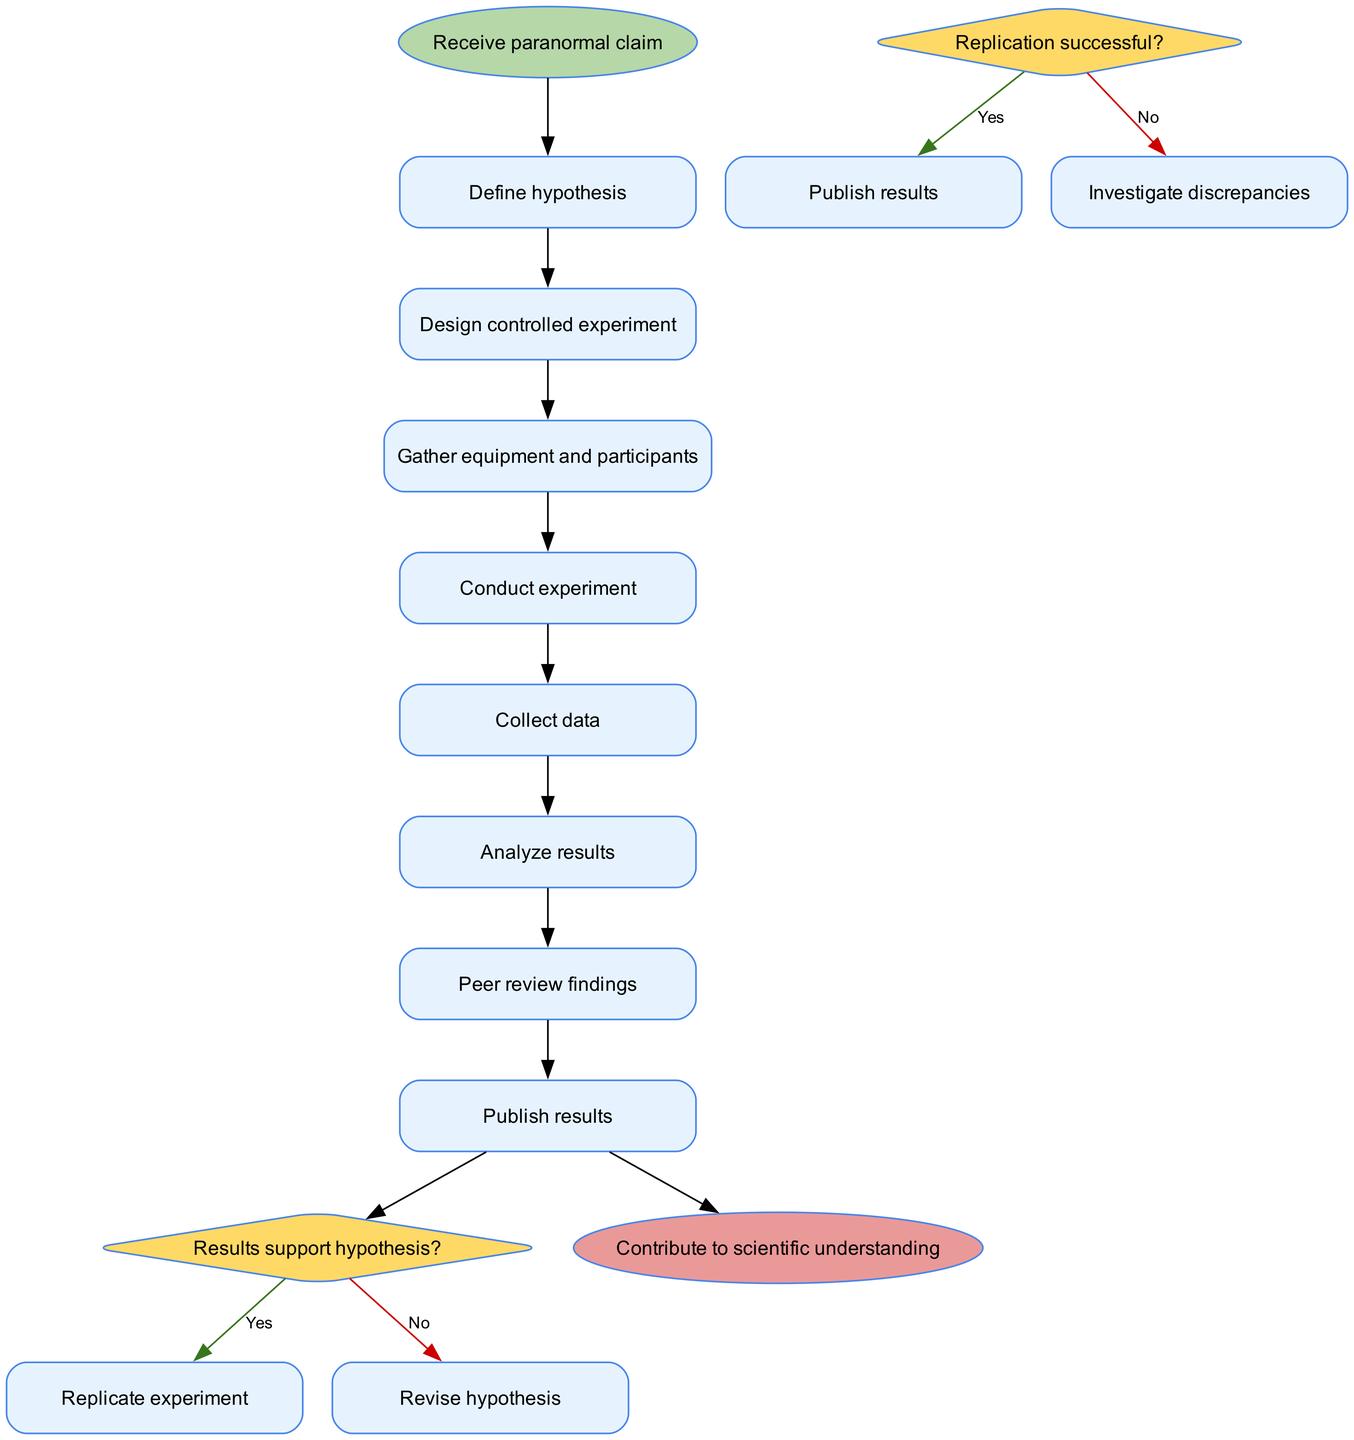What is the first activity in the diagram? The first activity is identified by its position and connection in the diagram, which follows the start node. It is labeled as "Define hypothesis."
Answer: Define hypothesis How many activities are present in the diagram? By counting each listed activity from the diagram data, there are a total of 8 activities mentioned.
Answer: 8 What happens if the results do not support the hypothesis? This can be deduced by tracing the decision flow from the "Results support hypothesis?" decision node; if the answer is "No," the next step is to "Revise hypothesis."
Answer: Revise hypothesis Which node leads to collecting data? The node that leads to "Collect data" is "Conduct experiment" as it is the previous activity in the sequence.
Answer: Conduct experiment What is the conclusion after publishing results? The conclusion is indicated by the final node that follows all processes in the diagram, which is to "Contribute to scientific understanding."
Answer: Contribute to scientific understanding How does the diagram handle unsuccessful replication? In the case of unsuccessful replication, referring to the decision node "Replication successful?" leads to the next step "Investigate discrepancies."
Answer: Investigate discrepancies What is the last decision point present in the diagram? The last decision is found after analyzing results, specifically at the "Replication successful?" node, which determines the ensuing steps following the analysis.
Answer: Replication successful? What occurs after conducting the experiment? After the "Conduct experiment" activity, the next node is "Collect data," which indicates the sequence of actions following the experiment.
Answer: Collect data What is the shape of the start node? The shape of the start node is mentioned in the diagram specifications, and it is defined as an "ellipse."
Answer: ellipse 